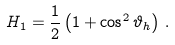Convert formula to latex. <formula><loc_0><loc_0><loc_500><loc_500>H _ { 1 } = \frac { 1 } { 2 } \left ( 1 + \cos ^ { 2 } \vartheta _ { h } \right ) \, .</formula> 